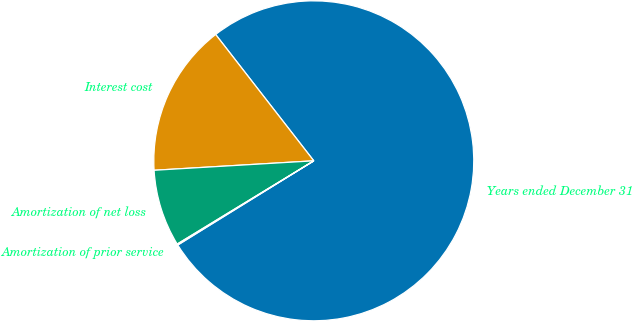Convert chart. <chart><loc_0><loc_0><loc_500><loc_500><pie_chart><fcel>Years ended December 31<fcel>Interest cost<fcel>Amortization of net loss<fcel>Amortization of prior service<nl><fcel>76.69%<fcel>15.43%<fcel>7.77%<fcel>0.11%<nl></chart> 